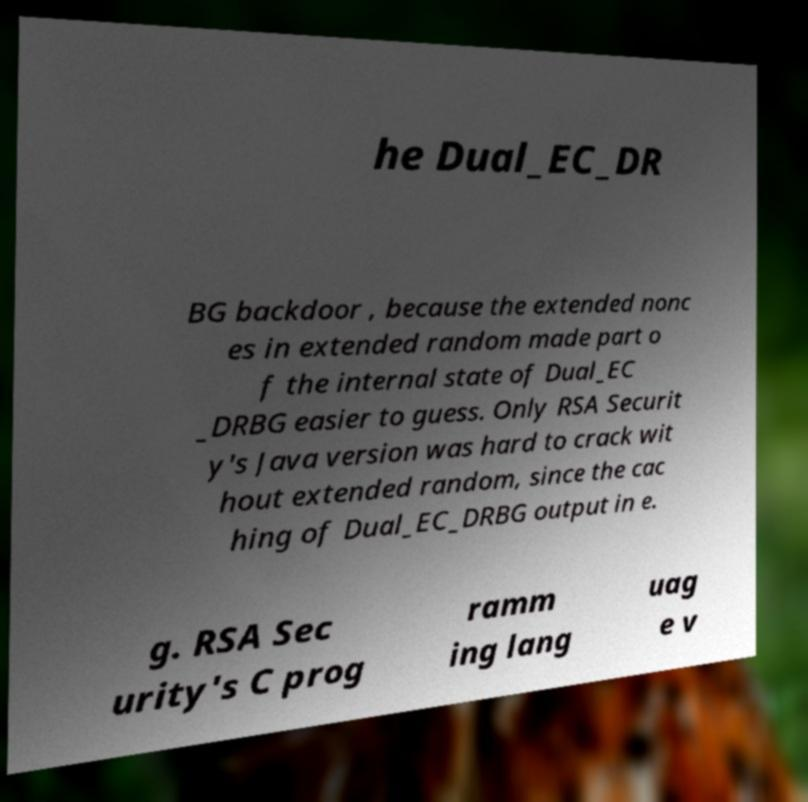Please read and relay the text visible in this image. What does it say? he Dual_EC_DR BG backdoor , because the extended nonc es in extended random made part o f the internal state of Dual_EC _DRBG easier to guess. Only RSA Securit y's Java version was hard to crack wit hout extended random, since the cac hing of Dual_EC_DRBG output in e. g. RSA Sec urity's C prog ramm ing lang uag e v 